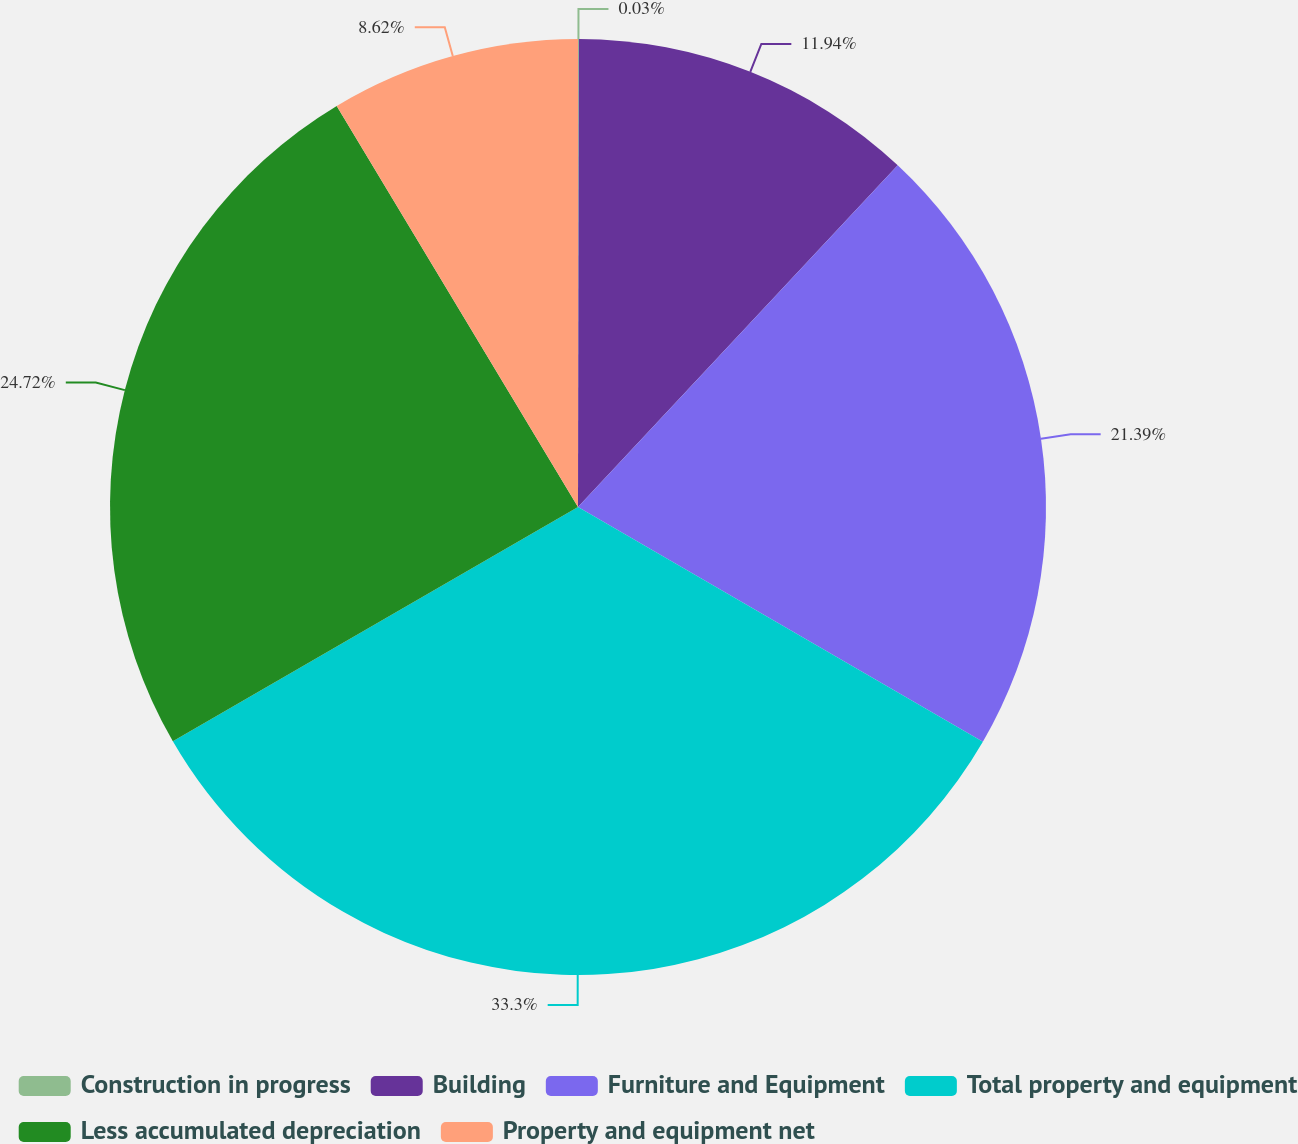Convert chart. <chart><loc_0><loc_0><loc_500><loc_500><pie_chart><fcel>Construction in progress<fcel>Building<fcel>Furniture and Equipment<fcel>Total property and equipment<fcel>Less accumulated depreciation<fcel>Property and equipment net<nl><fcel>0.03%<fcel>11.94%<fcel>21.39%<fcel>33.29%<fcel>24.72%<fcel>8.62%<nl></chart> 